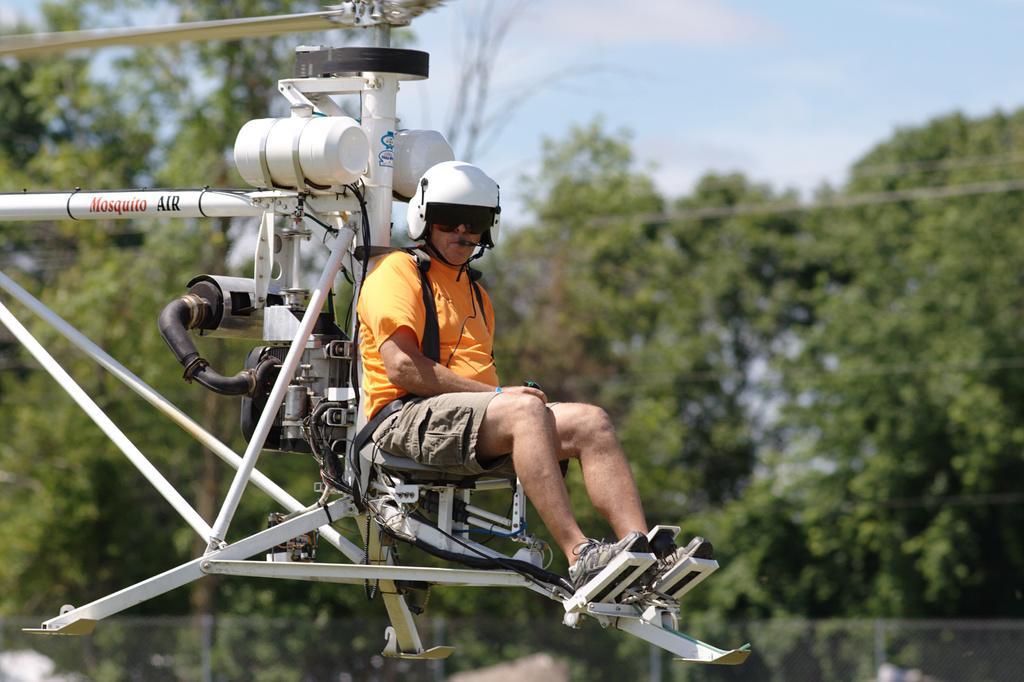Describe this image in one or two sentences. In this picture there is a man sitting on a seat and we can see an aircraft. In the background of the image it is blurry and we can see trees and sky. 